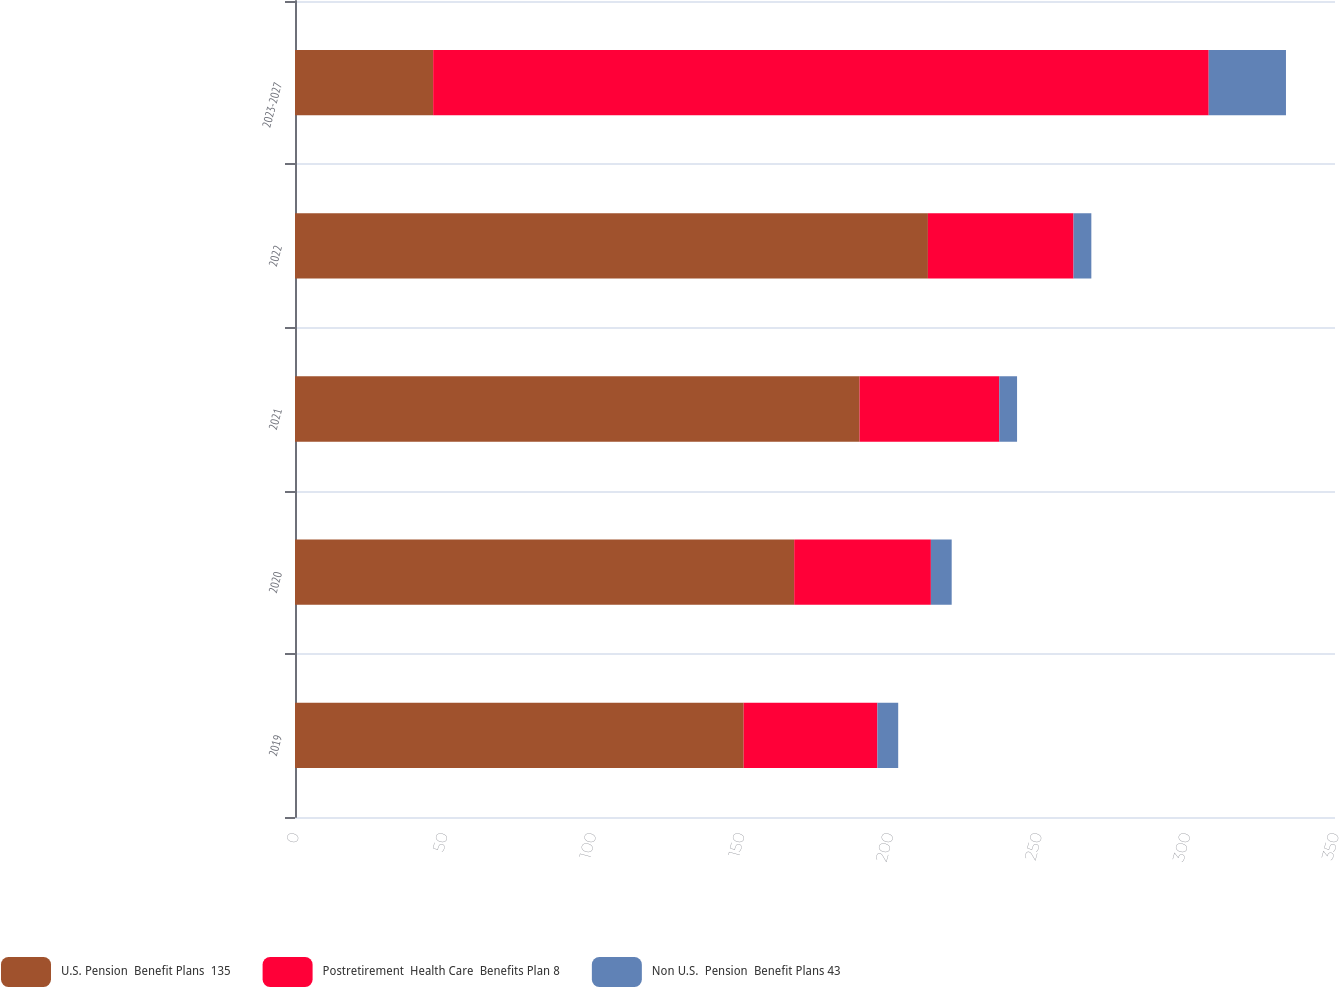Convert chart. <chart><loc_0><loc_0><loc_500><loc_500><stacked_bar_chart><ecel><fcel>2019<fcel>2020<fcel>2021<fcel>2022<fcel>2023-2027<nl><fcel>U.S. Pension  Benefit Plans  135<fcel>151<fcel>168<fcel>190<fcel>213<fcel>46.5<nl><fcel>Postretirement  Health Care  Benefits Plan 8<fcel>45<fcel>46<fcel>47<fcel>49<fcel>261<nl><fcel>Non U.S.  Pension  Benefit Plans 43<fcel>7<fcel>7<fcel>6<fcel>6<fcel>26<nl></chart> 